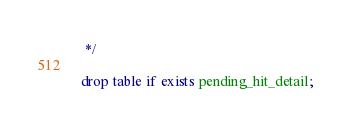<code> <loc_0><loc_0><loc_500><loc_500><_SQL_> */

drop table if exists pending_hit_detail;

</code> 